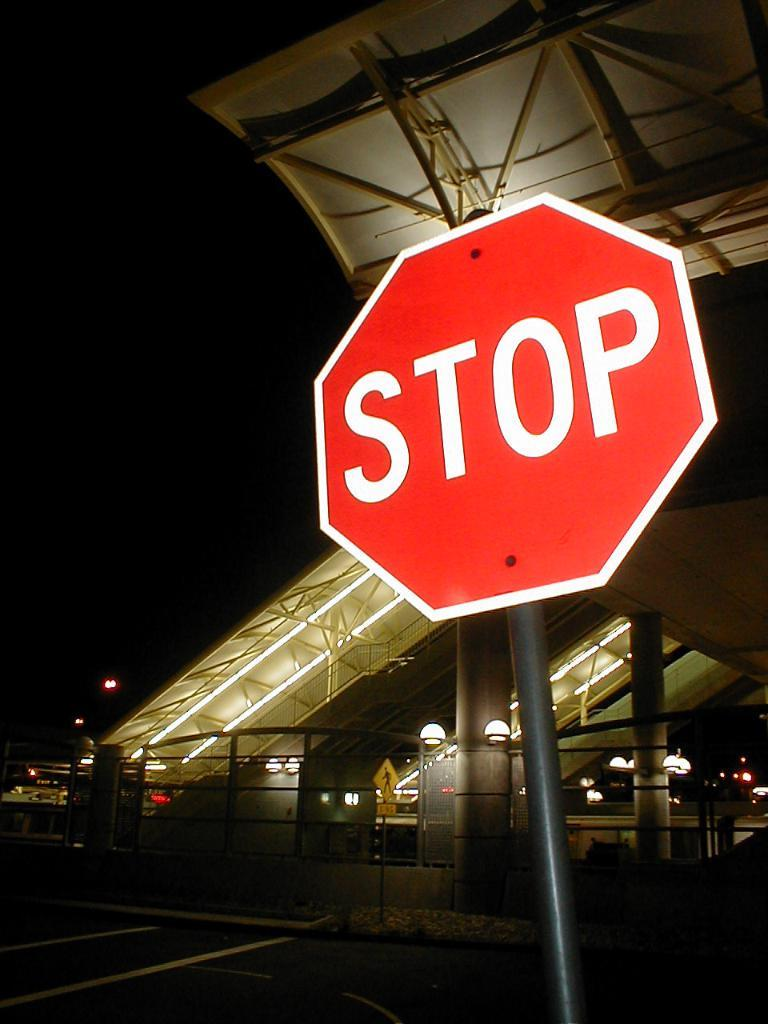<image>
Share a concise interpretation of the image provided. A Stop Sign stands on a dark street with a lighted stairway in the background. 